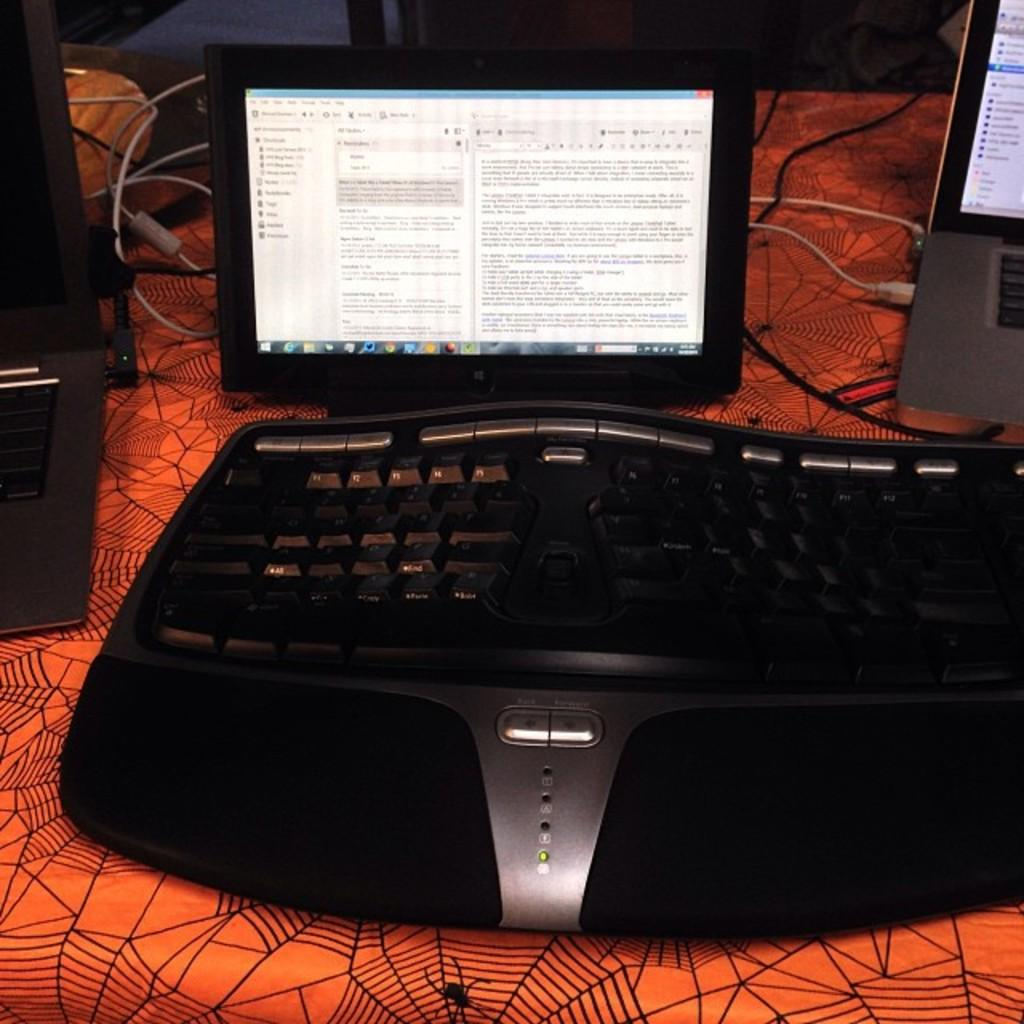What electronic device is visible in the image? There is a monitor and a laptop in the image. What is used for typing in the image? There is a keyboard in the image. What else can be seen on the table besides the electronic devices? There are other objects on the table. What color is the table cover in the image? The table is covered with an orange color cover. What type of doctor is standing next to the table in the image? There is no doctor present in the image; it only features electronic devices and other objects on a table. What type of stem is visible on the table in the image? There is no stem present in the image; it only features electronic devices and other objects on a table. 